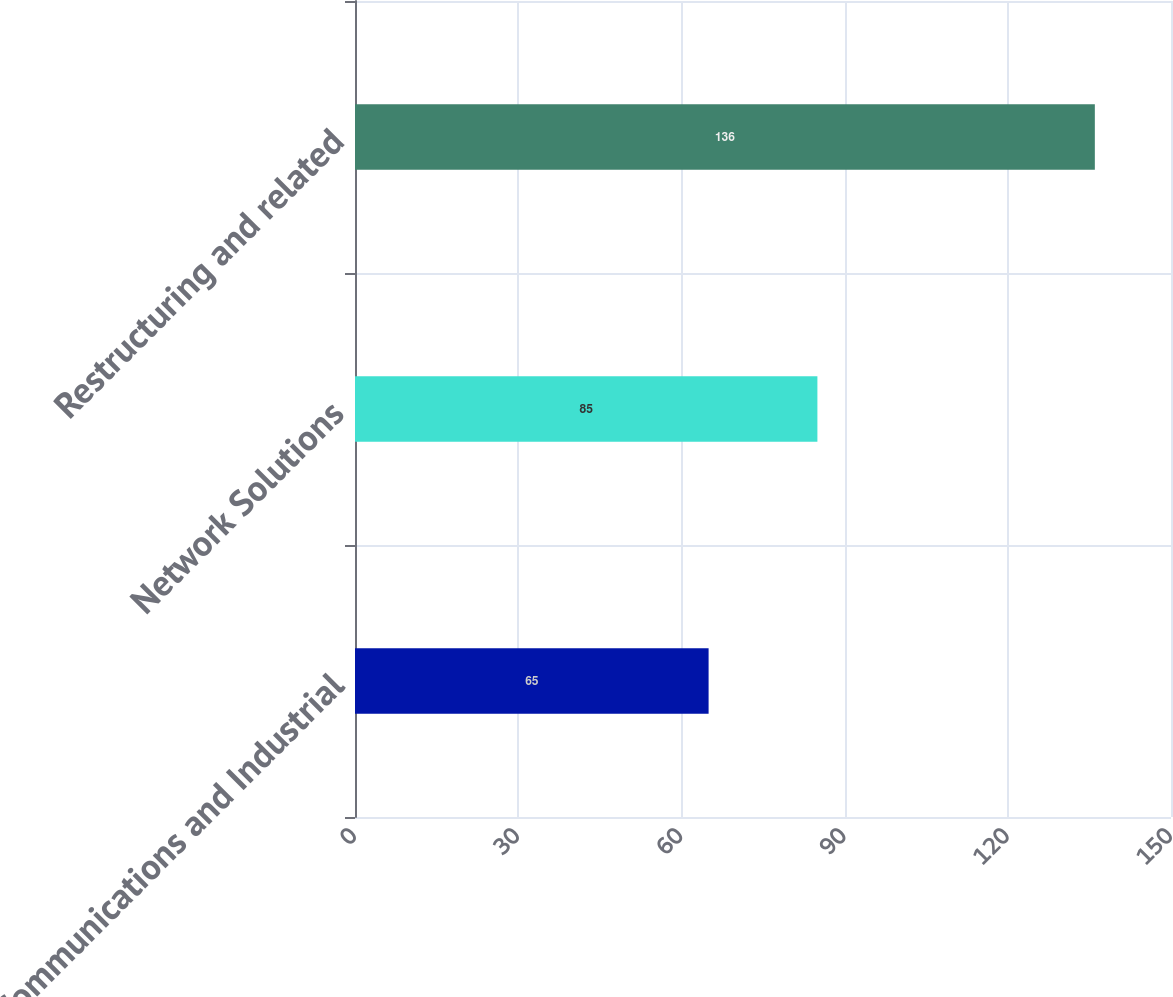<chart> <loc_0><loc_0><loc_500><loc_500><bar_chart><fcel>Communications and Industrial<fcel>Network Solutions<fcel>Restructuring and related<nl><fcel>65<fcel>85<fcel>136<nl></chart> 